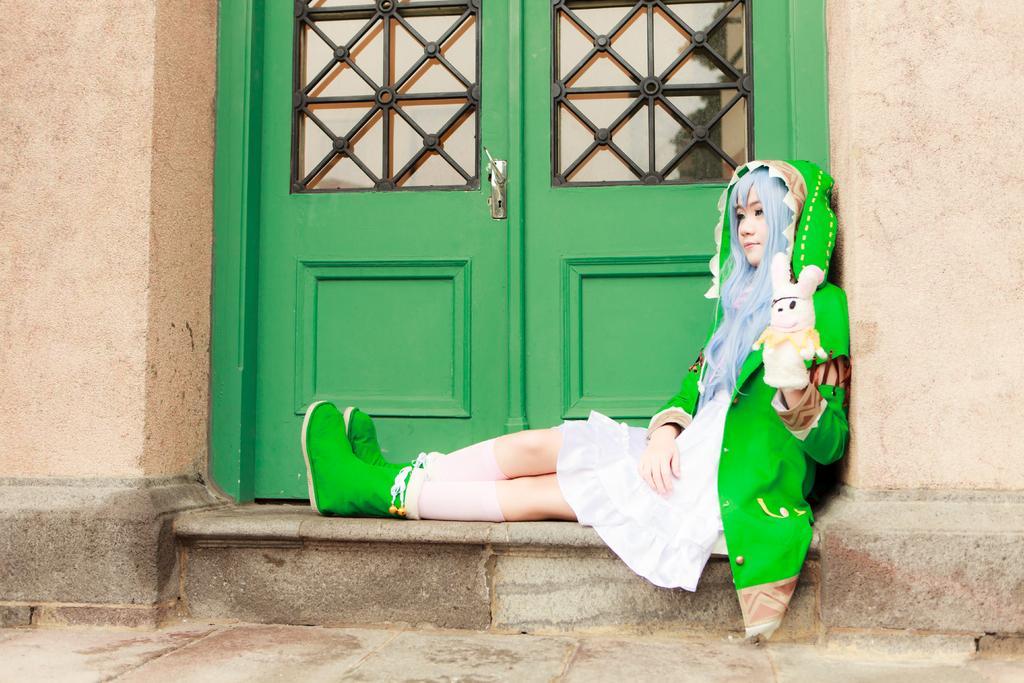In one or two sentences, can you explain what this image depicts? In this image I can see the ground, a building which is brown in color, a green colored door and a person wearing green and white colored dress is sitting in front of the door. 